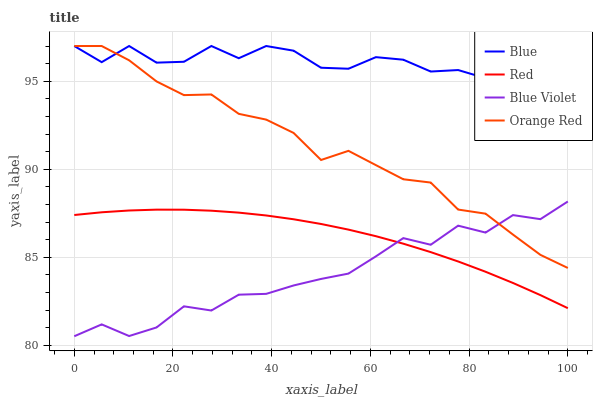Does Blue Violet have the minimum area under the curve?
Answer yes or no. Yes. Does Blue have the maximum area under the curve?
Answer yes or no. Yes. Does Red have the minimum area under the curve?
Answer yes or no. No. Does Red have the maximum area under the curve?
Answer yes or no. No. Is Red the smoothest?
Answer yes or no. Yes. Is Blue Violet the roughest?
Answer yes or no. Yes. Is Blue Violet the smoothest?
Answer yes or no. No. Is Red the roughest?
Answer yes or no. No. Does Blue Violet have the lowest value?
Answer yes or no. Yes. Does Red have the lowest value?
Answer yes or no. No. Does Orange Red have the highest value?
Answer yes or no. Yes. Does Blue Violet have the highest value?
Answer yes or no. No. Is Red less than Orange Red?
Answer yes or no. Yes. Is Orange Red greater than Red?
Answer yes or no. Yes. Does Blue intersect Orange Red?
Answer yes or no. Yes. Is Blue less than Orange Red?
Answer yes or no. No. Is Blue greater than Orange Red?
Answer yes or no. No. Does Red intersect Orange Red?
Answer yes or no. No. 